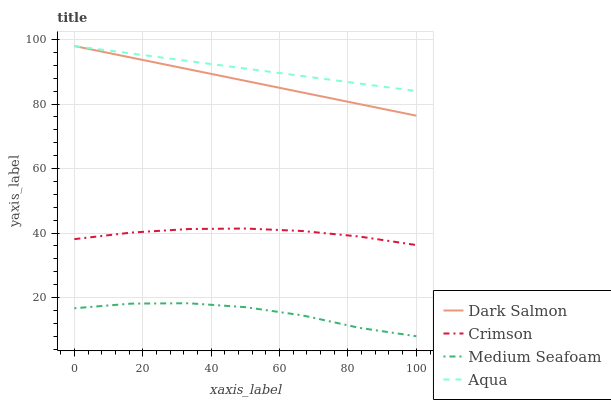Does Dark Salmon have the minimum area under the curve?
Answer yes or no. No. Does Dark Salmon have the maximum area under the curve?
Answer yes or no. No. Is Dark Salmon the smoothest?
Answer yes or no. No. Is Dark Salmon the roughest?
Answer yes or no. No. Does Dark Salmon have the lowest value?
Answer yes or no. No. Does Medium Seafoam have the highest value?
Answer yes or no. No. Is Medium Seafoam less than Crimson?
Answer yes or no. Yes. Is Aqua greater than Crimson?
Answer yes or no. Yes. Does Medium Seafoam intersect Crimson?
Answer yes or no. No. 